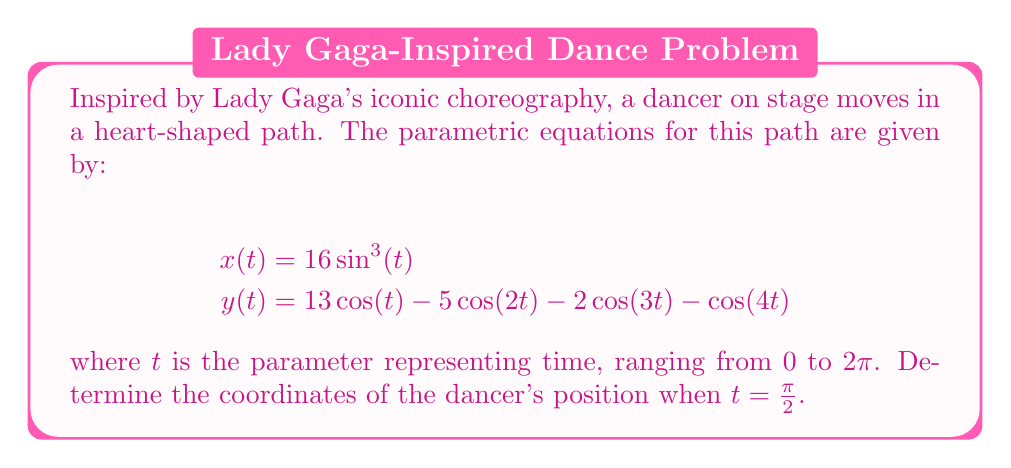Provide a solution to this math problem. To solve this problem, we need to follow these steps:

1. Understand the given parametric equations:
   $$x(t) = 16\sin^3(t)$$
   $$y(t) = 13\cos(t) - 5\cos(2t) - 2\cos(3t) - \cos(4t)$$

2. Substitute $t = \frac{\pi}{2}$ into both equations:

   For $x(\frac{\pi}{2})$:
   $$x(\frac{\pi}{2}) = 16\sin^3(\frac{\pi}{2})$$
   
   We know that $\sin(\frac{\pi}{2}) = 1$, so:
   $$x(\frac{\pi}{2}) = 16(1)^3 = 16$$

   For $y(\frac{\pi}{2})$:
   $$y(\frac{\pi}{2}) = 13\cos(\frac{\pi}{2}) - 5\cos(2\cdot\frac{\pi}{2}) - 2\cos(3\cdot\frac{\pi}{2}) - \cos(4\cdot\frac{\pi}{2})$$
   
   Simplify:
   $$y(\frac{\pi}{2}) = 13\cos(\frac{\pi}{2}) - 5\cos(\pi) - 2\cos(\frac{3\pi}{2}) - \cos(2\pi)$$
   
   We know that:
   $\cos(\frac{\pi}{2}) = 0$
   $\cos(\pi) = -1$
   $\cos(\frac{3\pi}{2}) = 0$
   $\cos(2\pi) = 1$
   
   Substituting these values:
   $$y(\frac{\pi}{2}) = 13(0) - 5(-1) - 2(0) - 1 = 5 - 1 = 4$$

3. Combine the results to get the coordinates:
   The dancer's position at $t = \frac{\pi}{2}$ is $(16, 4)$.
Answer: $(16, 4)$ 